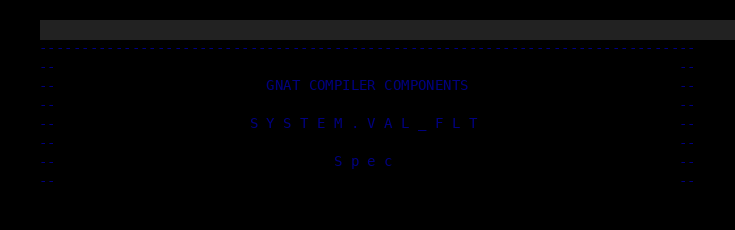Convert code to text. <code><loc_0><loc_0><loc_500><loc_500><_Ada_>------------------------------------------------------------------------------
--                                                                          --
--                         GNAT COMPILER COMPONENTS                         --
--                                                                          --
--                       S Y S T E M . V A L _ F L T                        --
--                                                                          --
--                                 S p e c                                  --
--                                                                          --</code> 